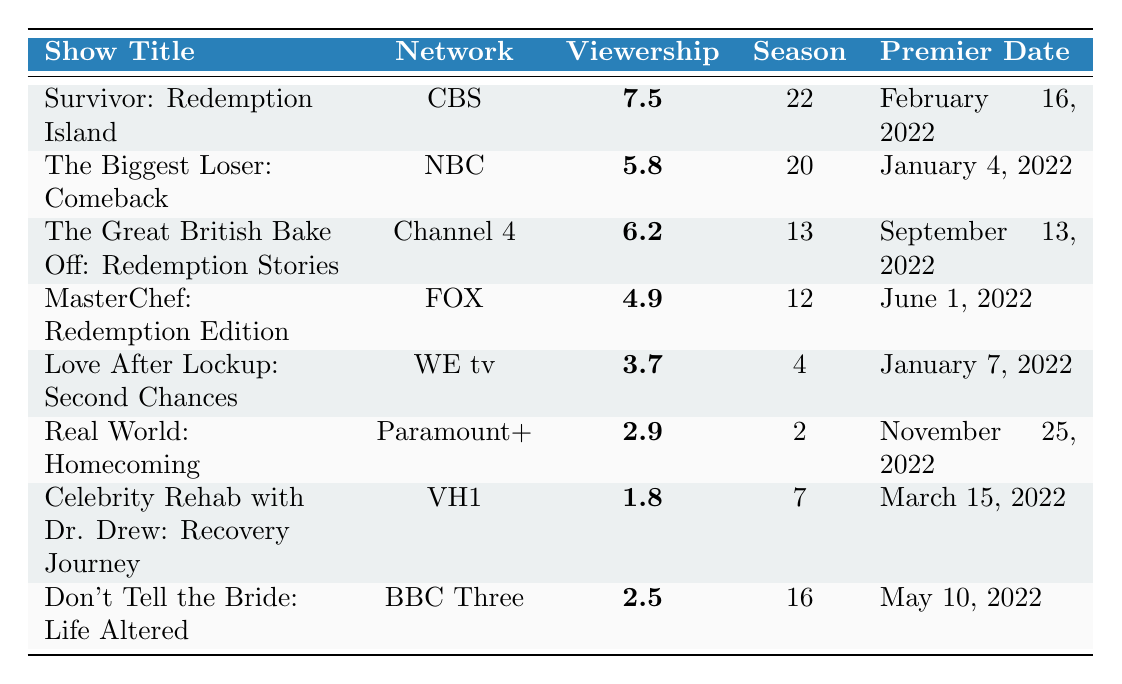What is the highest viewership rating among the reality TV shows listed? The ratings are 7.5, 5.8, 6.2, 4.9, 3.7, 2.9, 1.8, and 2.5. The highest value among these is 7.5, corresponding to "Survivor: Redemption Island".
Answer: 7.5 Which show has the lowest viewership rating? The ratings in the table include 7.5, 5.8, 6.2, 4.9, 3.7, 2.9, 1.8, and 2.5. The lowest value is 1.8 from "Celebrity Rehab with Dr. Drew: Recovery Journey".
Answer: 1.8 How many shows had a viewership rating above 5? The shows with ratings above 5 are "Survivor: Redemption Island" (7.5), "The Biggest Loser: Comeback" (5.8), and "The Great British Bake Off: Redemption Stories" (6.2). Counting these, there are three shows.
Answer: 3 What is the average viewership rating of the shows in the list? The viewership ratings are 7.5, 5.8, 6.2, 4.9, 3.7, 2.9, 1.8, and 2.5. Adding these gives 35.3. There are 8 shows, so the average is 35.3 divided by 8, which equals 4.4125, rounded to 4.41.
Answer: 4.41 Does "Love After Lockup: Second Chances" have a higher viewership rating than "MasterChef: Redemption Edition"? The rating for "Love After Lockup: Second Chances" is 3.7, and for "MasterChef: Redemption Edition" it is 4.9. Since 3.7 is less than 4.9, the answer is no.
Answer: No What was the premier date of the show with the second highest viewership rating? The second highest rating is 6.2 for "The Great British Bake Off: Redemption Stories", which premiered on September 13, 2022.
Answer: September 13, 2022 Which network aired the show with the highest rating? The show with the highest rating, 7.5, is "Survivor: Redemption Island", which aired on CBS.
Answer: CBS If we were to arrange the shows in order of their viewership ratings from highest to lowest, which show would come third? The ratings in order from highest to lowest are 7.5 ("Survivor: Redemption Island"), 6.2 ("The Great British Bake Off: Redemption Stories"), and 5.8 ("The Biggest Loser: Comeback"). Thus, the third show would be "The Biggest Loser: Comeback".
Answer: The Biggest Loser: Comeback How many shows premiered on or after June 1, 2022? The shows premiering on or after June 1, 2022 are "MasterChef: Redemption Edition" (June 1), "Love After Lockup: Second Chances" (January 7), "Real World: Homecoming" (November 25), "Celebrity Rehab with Dr. Drew: Recovery Journey" (March 15), and "Don't Tell the Bride: Life Altered" (May 10). Counting these results in five shows.
Answer: 5 What is the difference in viewership ratings between the highest and lowest rated shows? The highest rated show has a rating of 7.5 and the lowest has a rating of 1.8. Subtracting these gives 7.5 - 1.8 = 5.7.
Answer: 5.7 